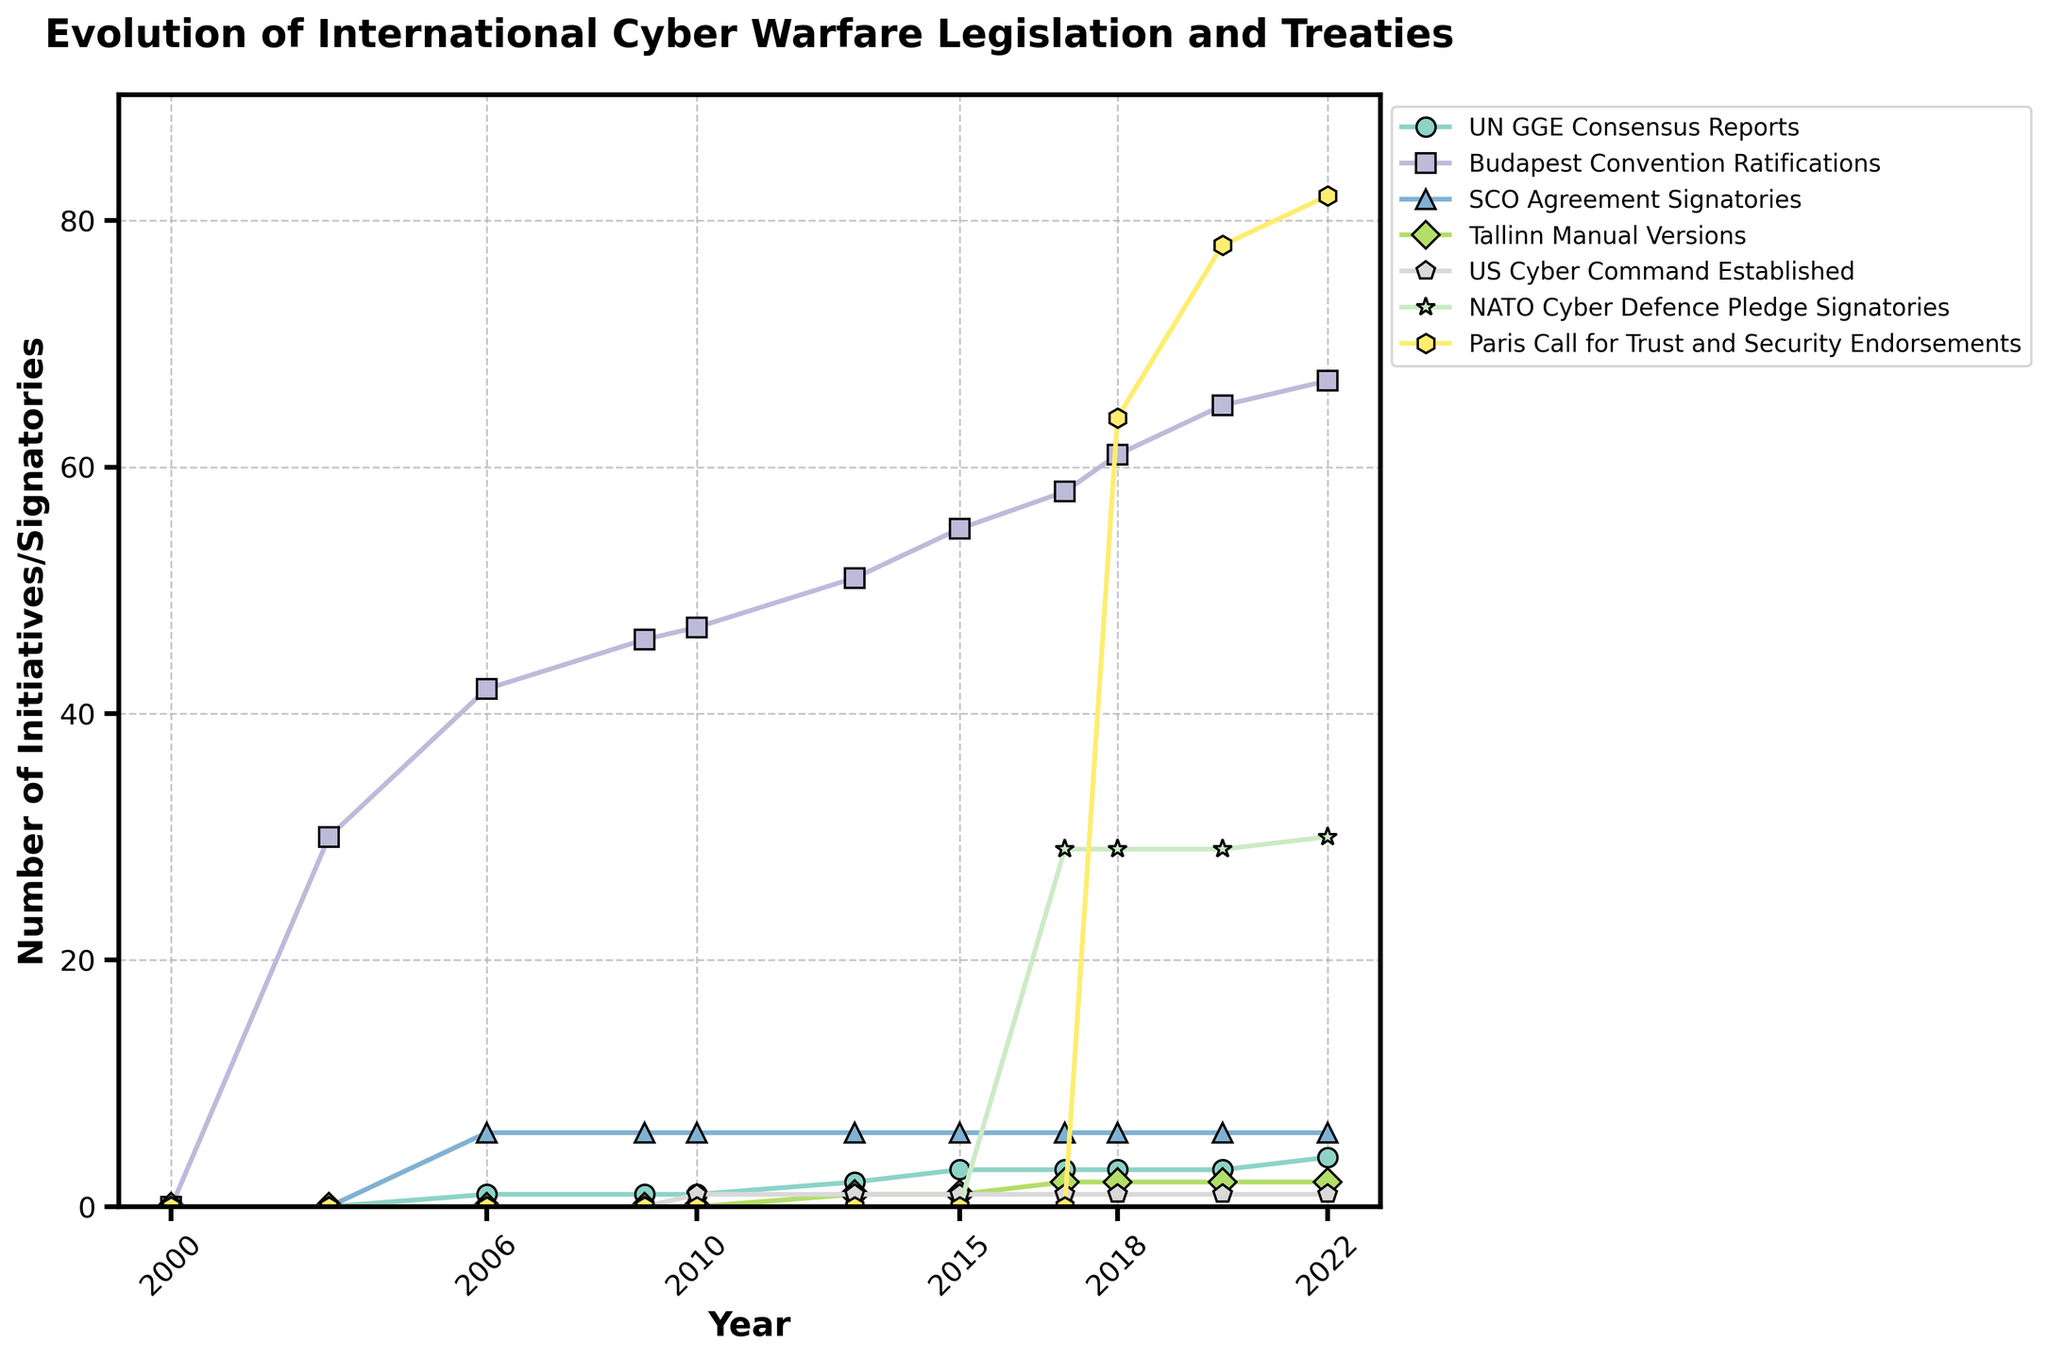Which initiative first appeared in 2010? In the figure, look for the year 2010 and identify the initiative that has its first non-zero value. The US Cyber Command was established in 2010 as indicated by the first appearance of a marker for that category.
Answer: US Cyber Command Established How many UN GGE Consensus Reports were there by 2022? Find the data series for UN GGE Consensus Reports and follow it to the year 2022. The value indicated is the count of reports by that year.
Answer: 4 Which has more signatories in 2020, the Budapest Convention or the Paris Call for Trust and Security? Compare the data points for Budapest Convention Ratifications and Paris Call for Trust and Security Endorsements in 2020. The Budapest Convention has 65 whereas the Paris Call has 78.
Answer: Paris Call for Trust and Security In which year did the number of Tallinn Manual Versions increase to 2? Follow the data series for Tallinn Manual Versions and identify the year when it increased from 1 to 2. It occurred in 2017.
Answer: 2017 What is the difference between the number of NATO Cyber Defence Pledge Signatories and Paris Call for Trust and Security Endorsements in 2022? For the year 2022, subtract the number of NATO Cyber Defence Pledge Signatories (30) from the number of Paris Call for Trust and Security Endorsements (82).
Answer: 52 Which initiative showed a consistent increase every recorded year from its inception? Review the trends for each initiative. The Budapest Convention Ratifications show consistent growth from 2003 to 2022.
Answer: Budapest Convention Ratifications How many years after the Budapest Convention was first ratified did the US Cyber Command establish? The Budapest Convention was first ratified in 2003 and US Cyber Command was established in 2010. Calculate the difference between these years.
Answer: 7 years What was the total number of initiatives or entities recorded in 2013? Sum all the initiatives for the year 2013 across all categories: 2 (UN GGE) + 51 (Budapest) + 6 (SCO Agreement) + 1 (Tallinn) + 1 (US Cyber) = 61.
Answer: 61 What trend can be observed for the UN GGE Consensus Reports from 2006 to 2022? Track the data points for UN GGE Consensus Reports from 2006 to 2022. They show a gradual increase, moving from 1 in 2006 to 4 in 2022.
Answer: Gradual increase 